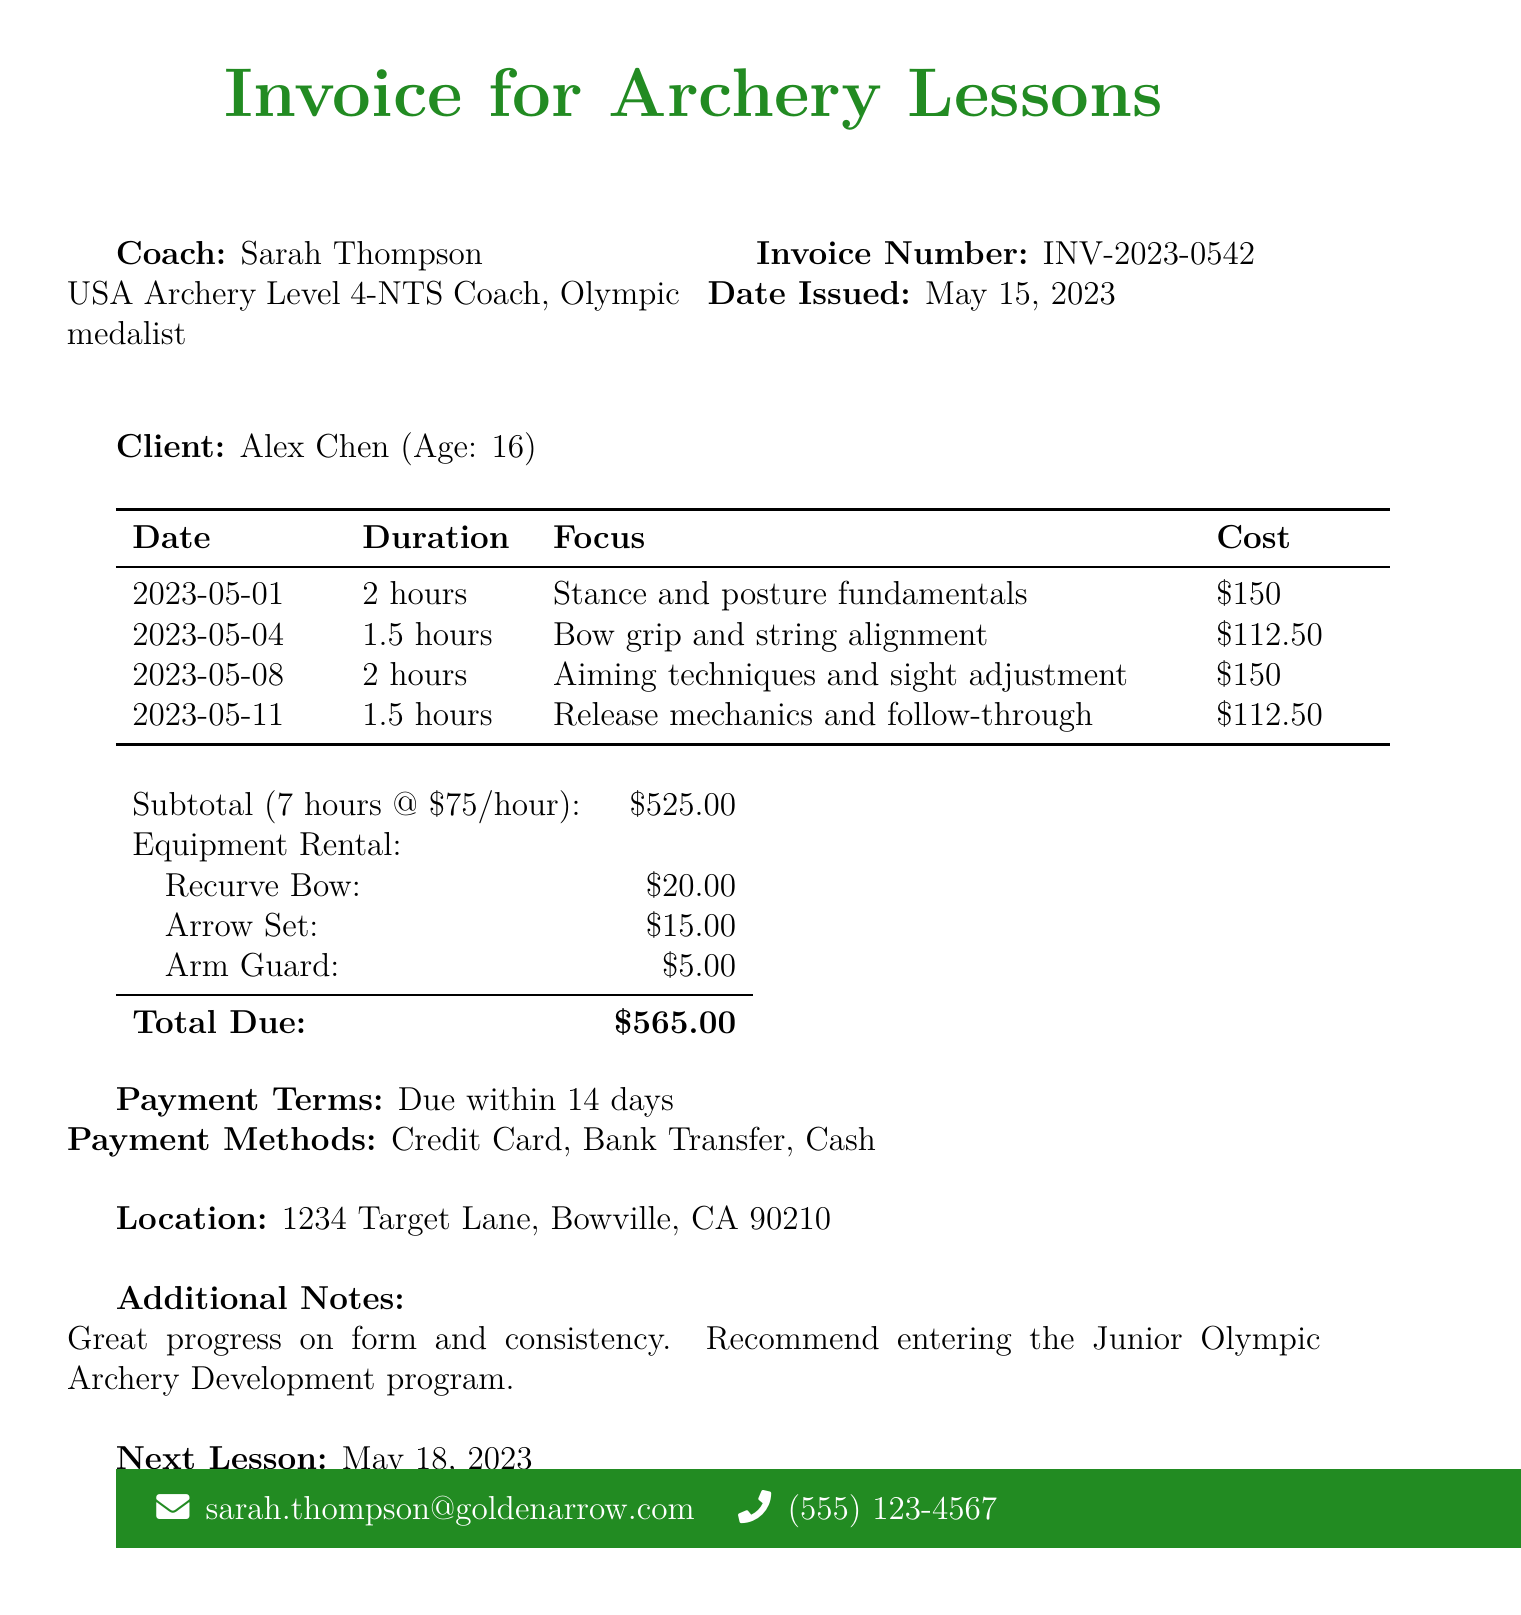What is the name of the coach? The coach's name is provided in the document, listed as "Sarah Thompson."
Answer: Sarah Thompson What is the date of the next lesson? The document states the date of the next lesson, which is "2023-05-18."
Answer: 2023-05-18 How many hours of lessons are detailed in the invoice? The total hours of lessons are calculated and mentioned in the document as "7."
Answer: 7 What is the subtotal amount for the lessons? The subtotal for the lessons is given directly in the document, which is "$525."
Answer: $525 What is the total amount due on the invoice? The total amount due is explicitly stated in the document as "$565."
Answer: $565 What is the focus of the lesson on May 4th? The specific focus for the lesson held on May 4th is detailed in the document, explicitly saying "Bow grip and string alignment."
Answer: Bow grip and string alignment How much is the rental for the recurve bow? The document provides the rental amount for the recurve bow as "$20."
Answer: $20 What payment methods are accepted? The invoice lists the available payment methods directly, which include "Credit Card, Bank Transfer, Cash."
Answer: Credit Card, Bank Transfer, Cash What is stated in the additional notes section of the invoice? The additional notes provide feedback on the client's progress and a recommendation, which is "Great progress on form and consistency. Recommend entering the Junior Olympic Archery Development program."
Answer: Great progress on form and consistency. Recommend entering the Junior Olympic Archery Development program 